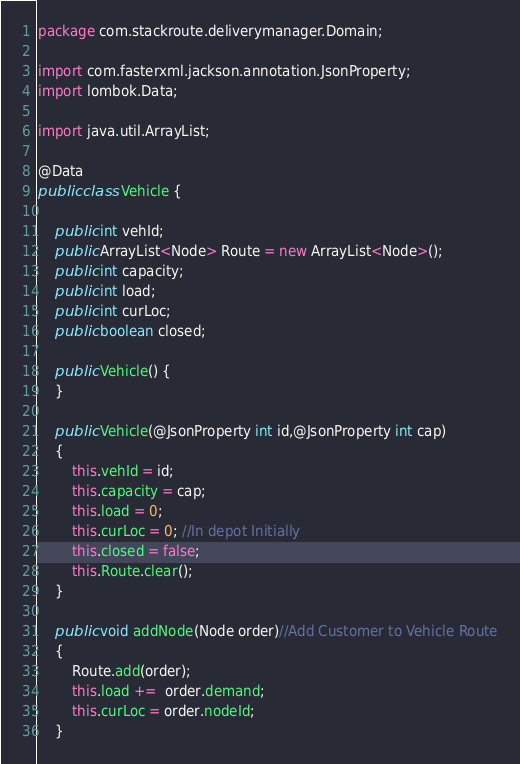<code> <loc_0><loc_0><loc_500><loc_500><_Java_>package com.stackroute.deliverymanager.Domain;

import com.fasterxml.jackson.annotation.JsonProperty;
import lombok.Data;

import java.util.ArrayList;

@Data
public class Vehicle {

    public int vehId;
    public ArrayList<Node> Route = new ArrayList<Node>();
    public int capacity;
    public int load;
    public int curLoc;
    public boolean closed;

    public Vehicle() {
    }

    public Vehicle(@JsonProperty int id,@JsonProperty int cap)
    {
        this.vehId = id;
        this.capacity = cap;
        this.load = 0;
        this.curLoc = 0; //In depot Initially
        this.closed = false;
        this.Route.clear();
    }

    public void addNode(Node order)//Add Customer to Vehicle Route
    {
        Route.add(order);
        this.load +=  order.demand;
        this.curLoc = order.nodeId;
    }
</code> 